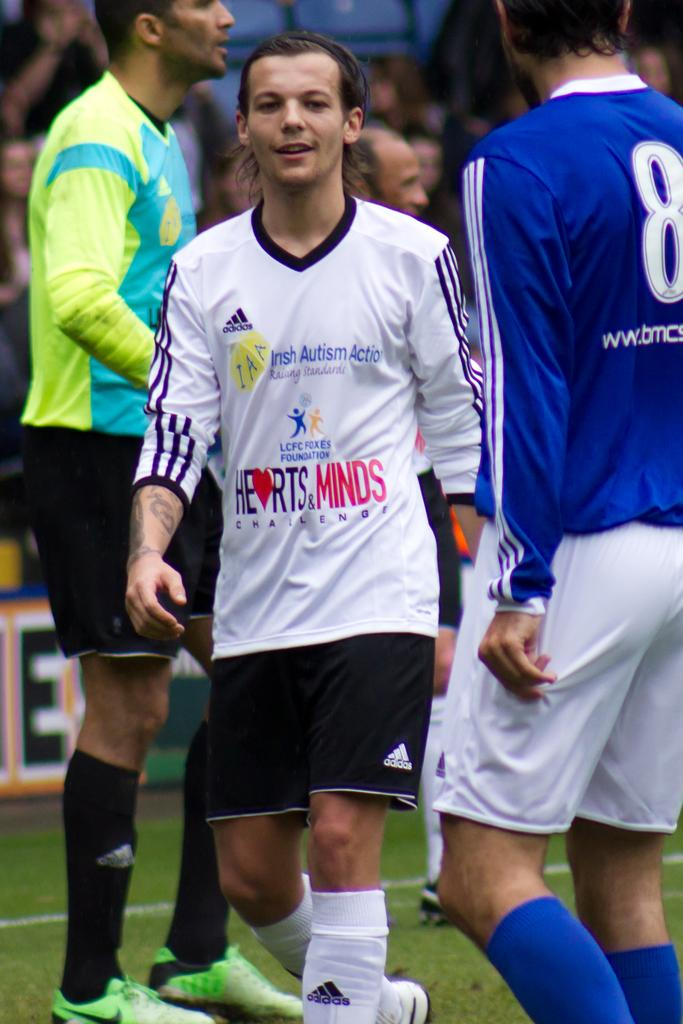<image>
Share a concise interpretation of the image provided. A man with the number 8 on his jersey is standing on a field. 